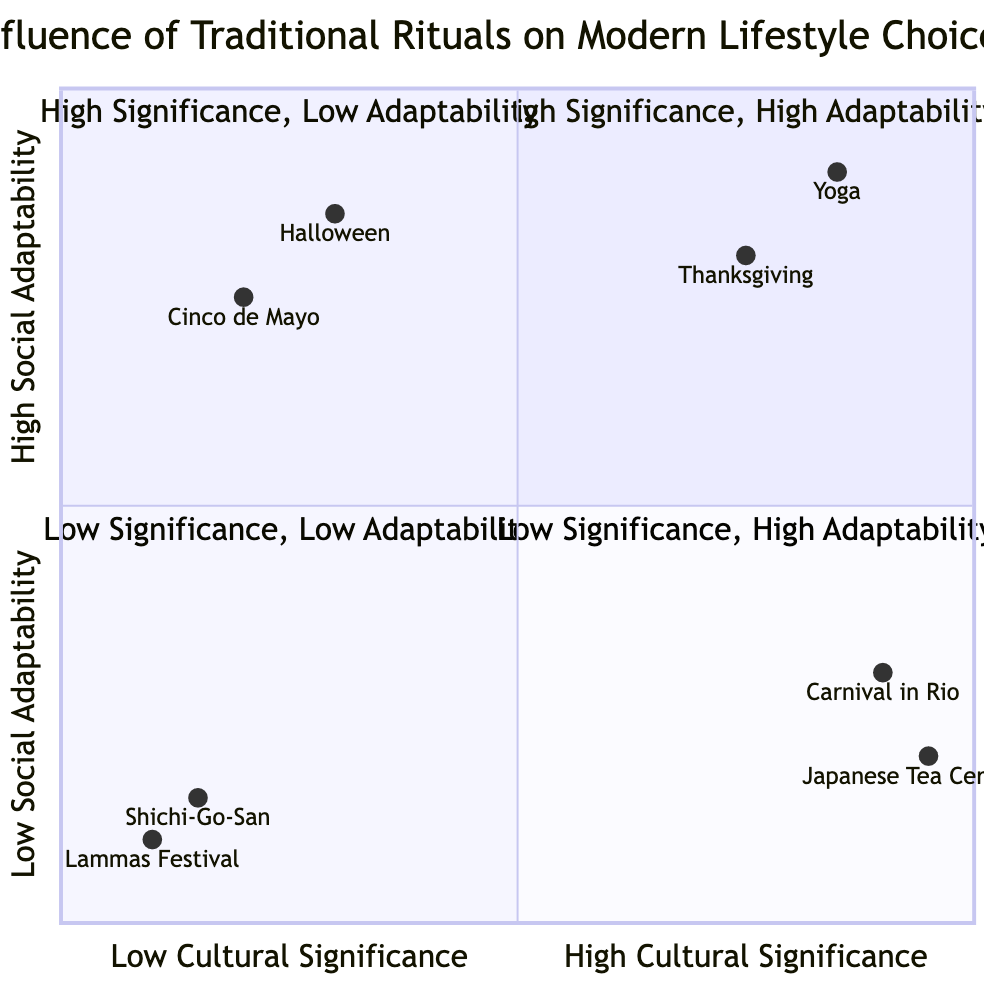What is the element with the highest cultural significance? The quadrant labeled "High Cultural Significance - Low Social Adaptability" contains the "Japanese Tea Ceremony", which has a very high cultural significance score near the maximum value of 0.95.
Answer: Japanese Tea Ceremony How many elements are in the quadrant with low social adaptability? In the quadrant "Low Social Adaptability", which includes both "Low Cultural Significance" and "High Cultural Significance", there are a total of four elements: "Japanese Tea Ceremony", "Carnival in Rio", "Lammas Festival", and "Shichi-Go-San".
Answer: 4 Which element has the highest social adaptability score? Upon examining the data, "Yoga" is positioned at the highest point in the quadrant with a social adaptability score of 0.9.
Answer: Yoga Identify the element in the "Low Cultural Significance - High Social Adaptability" quadrant. The elements listed in this quadrant include "Halloween" and "Cinco de Mayo". Among these, "Halloween" is a widely accepted celebration, indicating it is positioned here correctly.
Answer: Halloween Which quadrant contains the element with the lowest cultural significance score? The "Low Cultural Significance - Low Social Adaptability" quadrant, particularly includes "Lammas Festival" and "Shichi-Go-San", with "Lammas Festival" having the lowest cultural significance score at 0.1.
Answer: Lammas Festival What is the average social adaptability score of the elements in Q1? The elements "Thanksgiving Dinner" (0.8) and "Yoga" (0.9) in Q1 must be averaged to calculate the average social adaptability score, which is (0.8 + 0.9)/2 = 0.85.
Answer: 0.85 Name one element that is in the "High Cultural Significance - Low Social Adaptability" quadrant. The elements "Japanese Tea Ceremony" and "Carnival in Rio" represent this quadrant. Choosing either one can suffice.
Answer: Japanese Tea Ceremony How many quadrants contain elements with high cultural significance? There are two quadrants labeled as "High Cultural Significance", namely Q1 and Q2, indicating that a total of five elements exhibit high cultural significance across these quadrants.
Answer: 2 